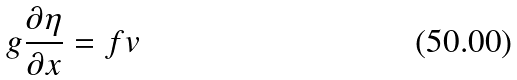<formula> <loc_0><loc_0><loc_500><loc_500>g \frac { \partial \eta } { \partial x } = f v</formula> 